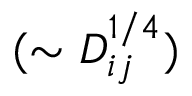Convert formula to latex. <formula><loc_0><loc_0><loc_500><loc_500>( \sim D _ { i j } ^ { 1 / 4 } )</formula> 